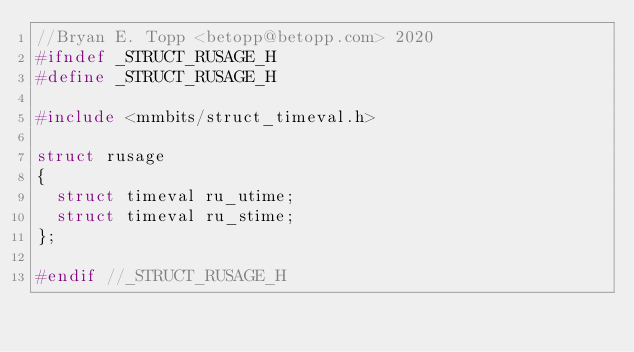Convert code to text. <code><loc_0><loc_0><loc_500><loc_500><_C_>//Bryan E. Topp <betopp@betopp.com> 2020
#ifndef _STRUCT_RUSAGE_H
#define _STRUCT_RUSAGE_H

#include <mmbits/struct_timeval.h>

struct rusage
{
	struct timeval ru_utime;
	struct timeval ru_stime;
};

#endif //_STRUCT_RUSAGE_H
</code> 